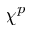<formula> <loc_0><loc_0><loc_500><loc_500>\chi ^ { p }</formula> 